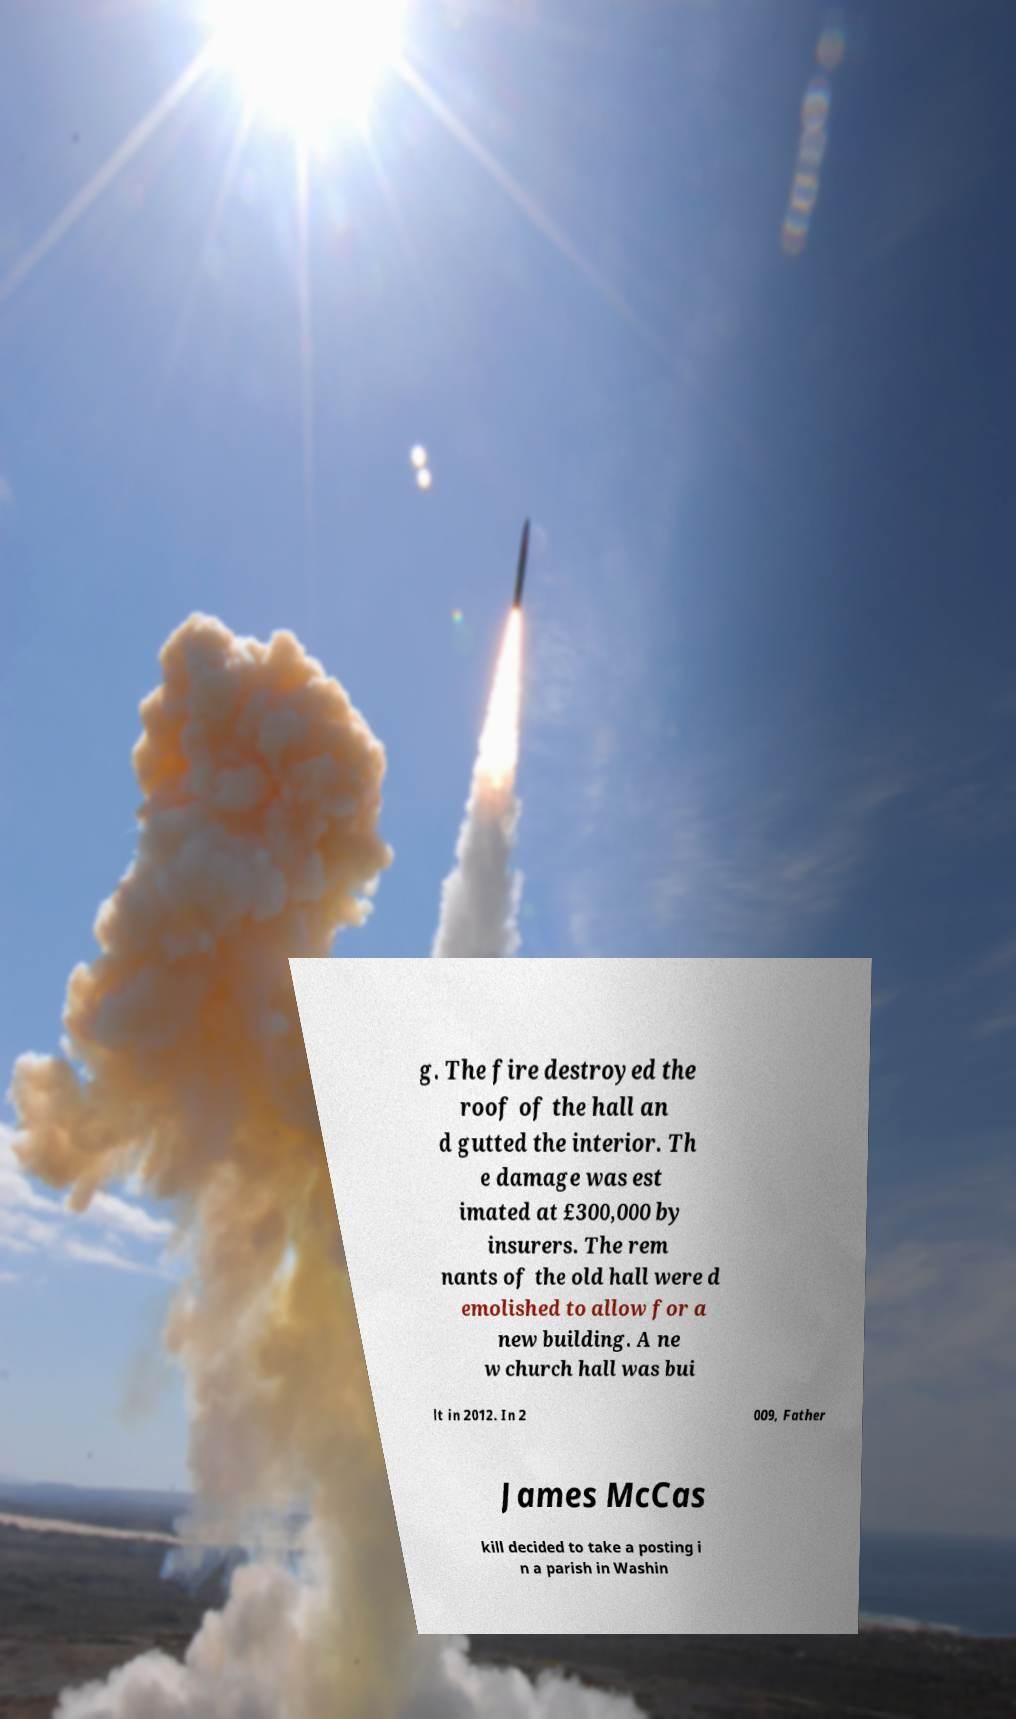I need the written content from this picture converted into text. Can you do that? g. The fire destroyed the roof of the hall an d gutted the interior. Th e damage was est imated at £300,000 by insurers. The rem nants of the old hall were d emolished to allow for a new building. A ne w church hall was bui lt in 2012. In 2 009, Father James McCas kill decided to take a posting i n a parish in Washin 